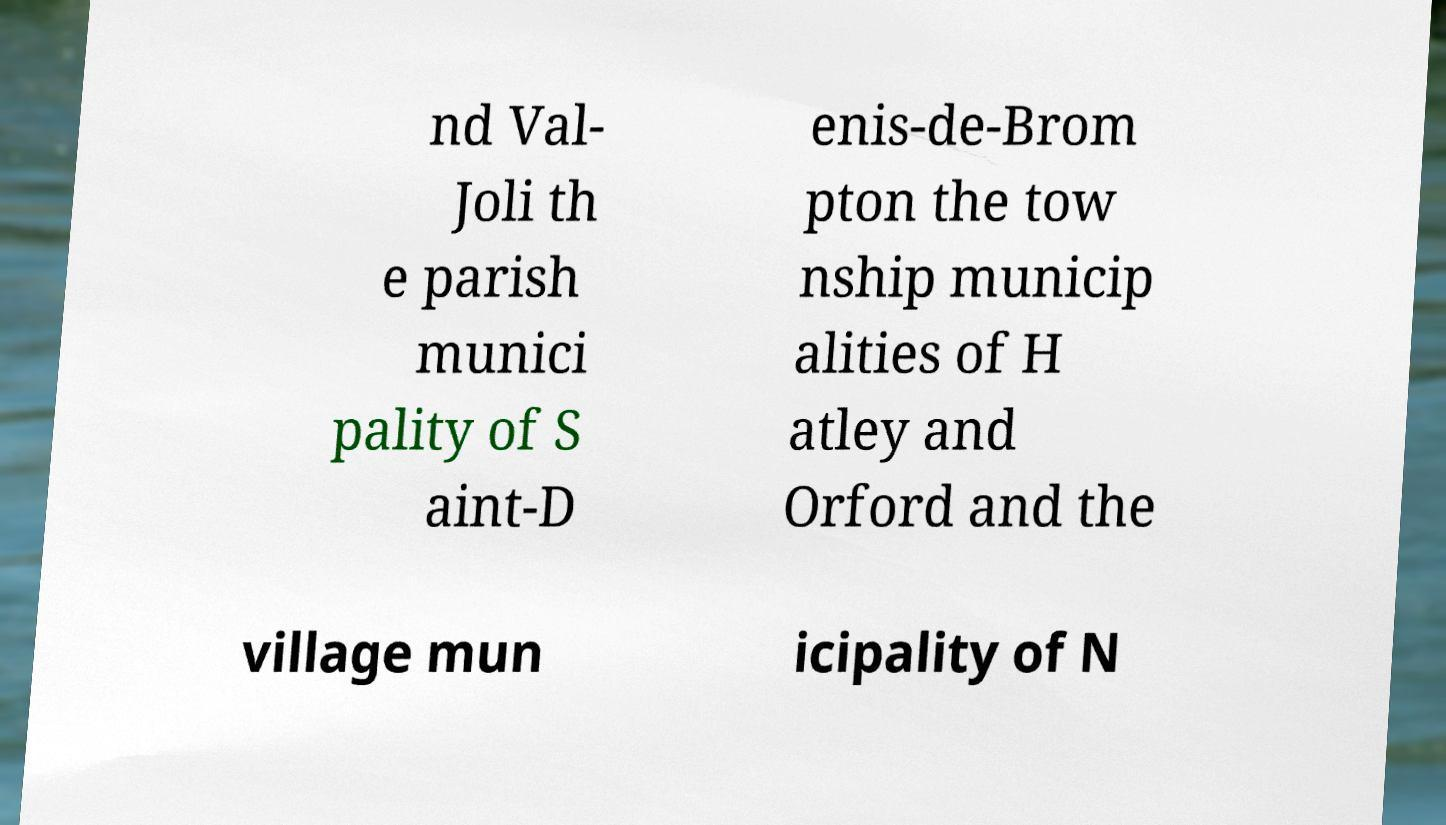There's text embedded in this image that I need extracted. Can you transcribe it verbatim? nd Val- Joli th e parish munici pality of S aint-D enis-de-Brom pton the tow nship municip alities of H atley and Orford and the village mun icipality of N 